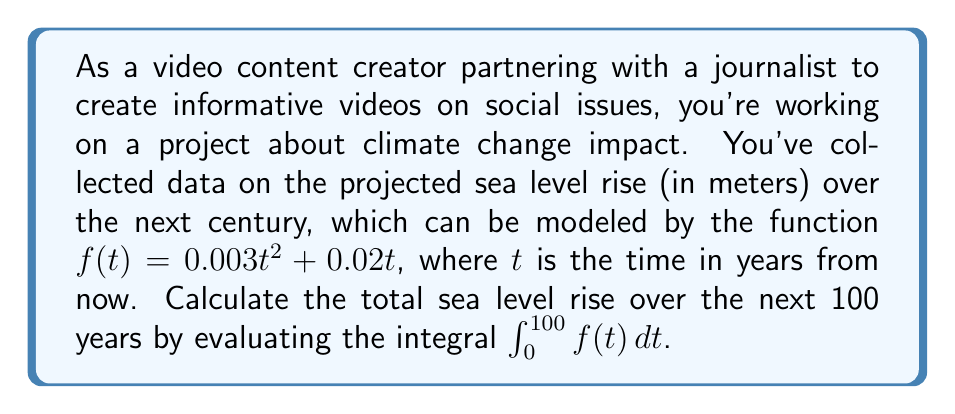What is the answer to this math problem? To solve this problem, we need to evaluate the definite integral of $f(t) = 0.003t^2 + 0.02t$ from $t=0$ to $t=100$. Let's break it down step by step:

1) First, let's set up the integral:

   $$\int_0^{100} (0.003t^2 + 0.02t) dt$$

2) We can integrate this polynomial term by term. Recall the power rule for integration:
   $\int x^n dx = \frac{x^{n+1}}{n+1} + C$

3) For the first term, $0.003t^2$:
   $$\int 0.003t^2 dt = 0.003 \cdot \frac{t^3}{3} = 0.001t^3$$

4) For the second term, $0.02t$:
   $$\int 0.02t dt = 0.02 \cdot \frac{t^2}{2} = 0.01t^2$$

5) Combining these results, we get the indefinite integral:
   $$\int (0.003t^2 + 0.02t) dt = 0.001t^3 + 0.01t^2 + C$$

6) Now, we need to evaluate this at the limits of integration. We'll use the fundamental theorem of calculus:

   $$\int_0^{100} f(t) dt = F(100) - F(0)$$

   where $F(t) = 0.001t^3 + 0.01t^2$

7) Let's evaluate:
   $F(100) = 0.001(100^3) + 0.01(100^2) = 10000 + 100 = 10100$
   $F(0) = 0.001(0^3) + 0.01(0^2) = 0$

8) Therefore, the definite integral is:
   $10100 - 0 = 10100$

This result represents the total sea level rise in meters over the next 100 years according to our model.
Answer: The total sea level rise over the next 100 years, calculated by evaluating $\int_0^{100} (0.003t^2 + 0.02t) dt$, is 10100 meters. 